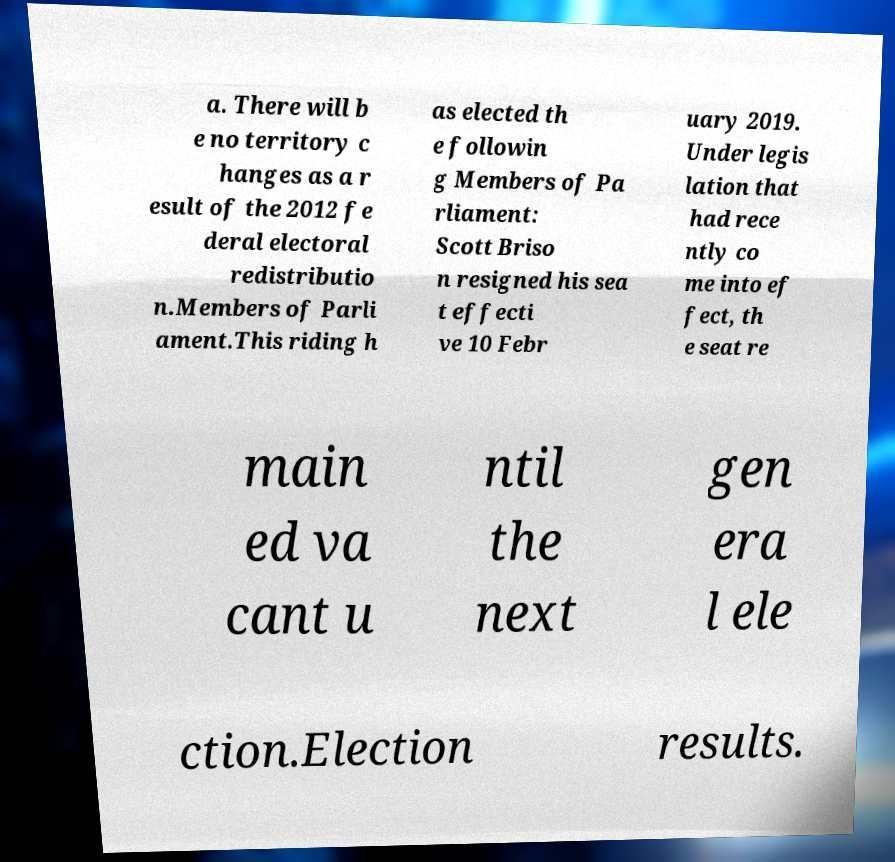There's text embedded in this image that I need extracted. Can you transcribe it verbatim? a. There will b e no territory c hanges as a r esult of the 2012 fe deral electoral redistributio n.Members of Parli ament.This riding h as elected th e followin g Members of Pa rliament: Scott Briso n resigned his sea t effecti ve 10 Febr uary 2019. Under legis lation that had rece ntly co me into ef fect, th e seat re main ed va cant u ntil the next gen era l ele ction.Election results. 